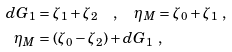Convert formula to latex. <formula><loc_0><loc_0><loc_500><loc_500>d G _ { 1 } & = \zeta _ { 1 } + \zeta _ { 2 } \quad , \quad \eta _ { M } = \zeta _ { 0 } + \zeta _ { 1 } \ , \\ \eta _ { M } & = ( \zeta _ { 0 } - \zeta _ { 2 } ) + d G _ { 1 } \ ,</formula> 